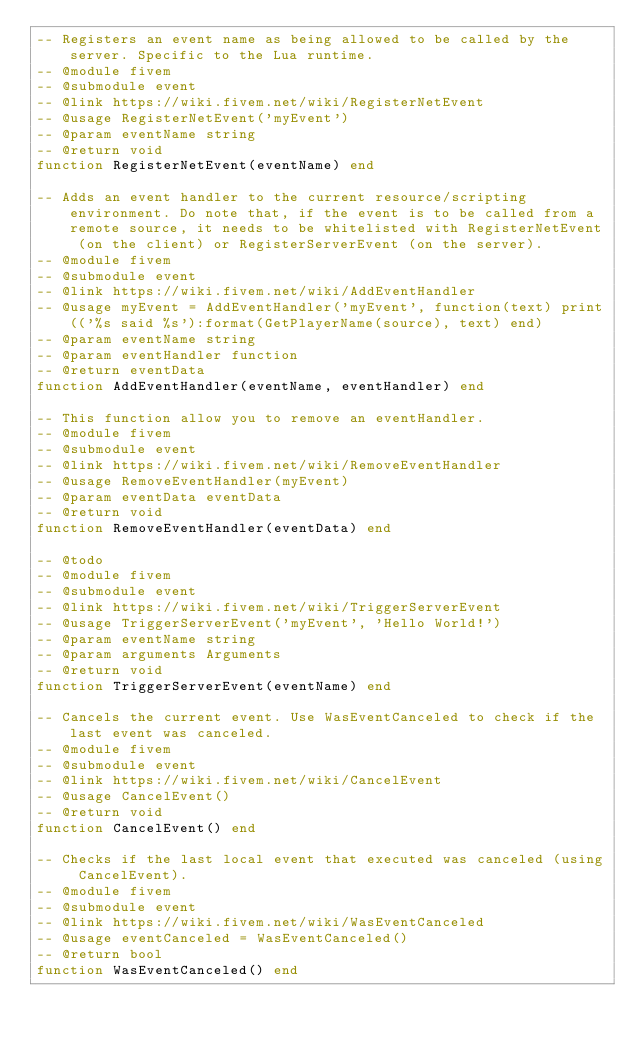<code> <loc_0><loc_0><loc_500><loc_500><_Lua_>-- Registers an event name as being allowed to be called by the server. Specific to the Lua runtime.
-- @module fivem
-- @submodule event
-- @link https://wiki.fivem.net/wiki/RegisterNetEvent
-- @usage RegisterNetEvent('myEvent')
-- @param eventName string
-- @return void
function RegisterNetEvent(eventName) end

-- Adds an event handler to the current resource/scripting environment. Do note that, if the event is to be called from a remote source, it needs to be whitelisted with RegisterNetEvent (on the client) or RegisterServerEvent (on the server).
-- @module fivem
-- @submodule event
-- @link https://wiki.fivem.net/wiki/AddEventHandler
-- @usage myEvent = AddEventHandler('myEvent', function(text) print(('%s said %s'):format(GetPlayerName(source), text) end)
-- @param eventName string
-- @param eventHandler function
-- @return eventData
function AddEventHandler(eventName, eventHandler) end

-- This function allow you to remove an eventHandler.
-- @module fivem
-- @submodule event
-- @link https://wiki.fivem.net/wiki/RemoveEventHandler
-- @usage RemoveEventHandler(myEvent)
-- @param eventData eventData
-- @return void
function RemoveEventHandler(eventData) end

-- @todo
-- @module fivem
-- @submodule event
-- @link https://wiki.fivem.net/wiki/TriggerServerEvent
-- @usage TriggerServerEvent('myEvent', 'Hello World!')
-- @param eventName string
-- @param arguments Arguments
-- @return void
function TriggerServerEvent(eventName) end

-- Cancels the current event. Use WasEventCanceled to check if the last event was canceled.
-- @module fivem
-- @submodule event
-- @link https://wiki.fivem.net/wiki/CancelEvent
-- @usage CancelEvent()
-- @return void
function CancelEvent() end

-- Checks if the last local event that executed was canceled (using CancelEvent).
-- @module fivem
-- @submodule event
-- @link https://wiki.fivem.net/wiki/WasEventCanceled
-- @usage eventCanceled = WasEventCanceled()
-- @return bool
function WasEventCanceled() end</code> 